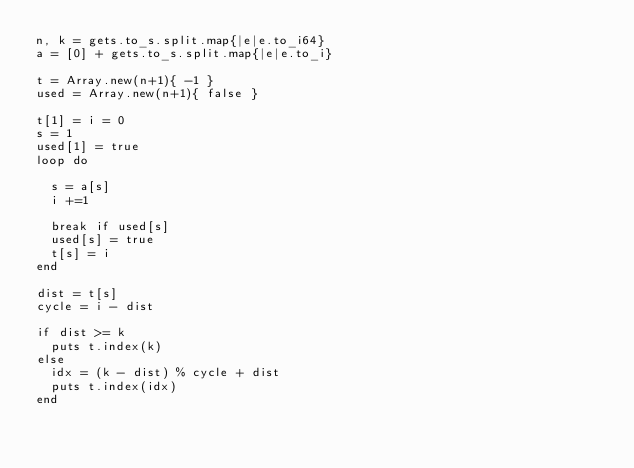<code> <loc_0><loc_0><loc_500><loc_500><_Crystal_>n, k = gets.to_s.split.map{|e|e.to_i64}
a = [0] + gets.to_s.split.map{|e|e.to_i}
 
t = Array.new(n+1){ -1 } 
used = Array.new(n+1){ false }

t[1] = i = 0
s = 1
used[1] = true
loop do
  
  s = a[s]
  i +=1
  
  break if used[s]
  used[s] = true
  t[s] = i
end

dist = t[s]
cycle = i - dist

if dist >= k
  puts t.index(k)
else
  idx = (k - dist) % cycle + dist
  puts t.index(idx)
end</code> 